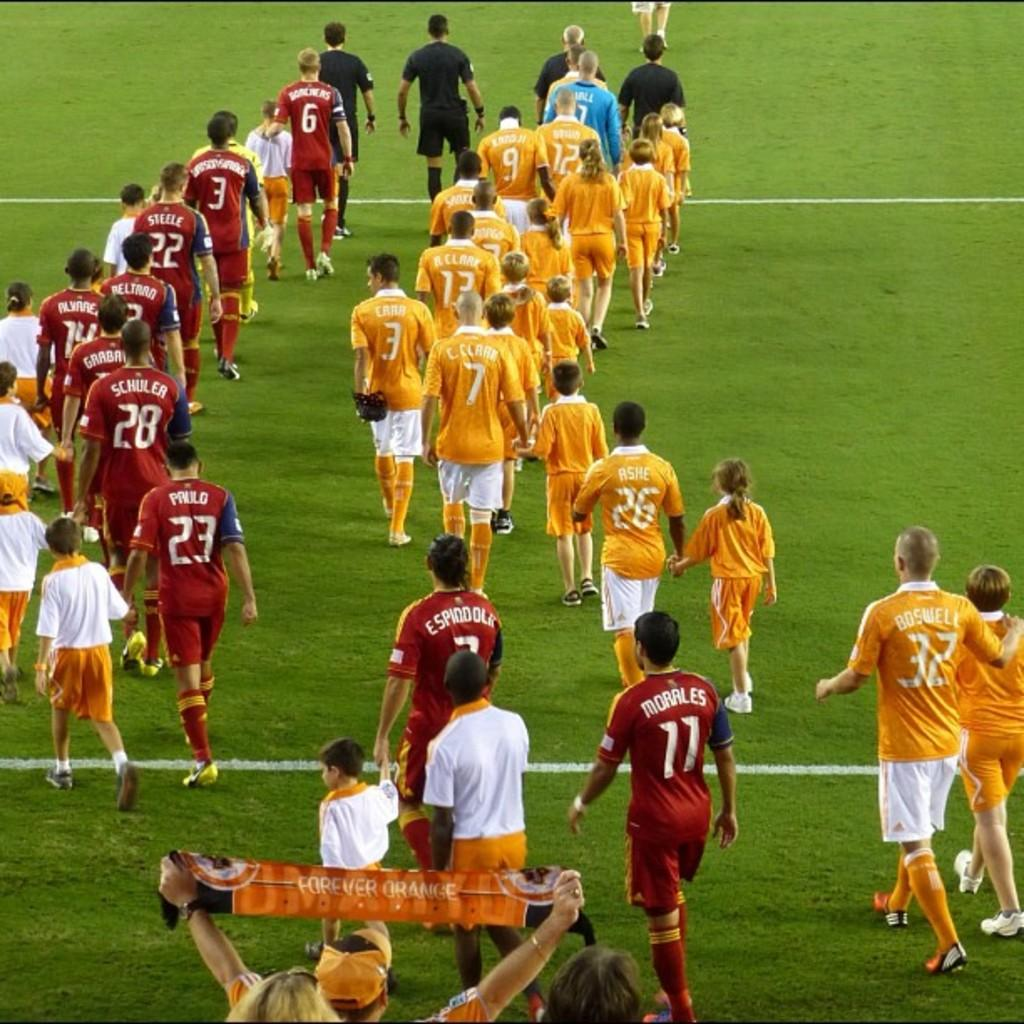How many people are in the image? There is a group of people in the image. What is the setting of the image? The people are standing on a grass field. Is there any text visible in the image? Yes, there is a person holding a banner with text in the image. Where is the banner located in the image? The banner is at the bottom of the image. Can you see the person's father in the image? There is no information about the person's father in the image, so we cannot determine if they are present or not. Is there a lake visible in the image? No, there is no lake present in the image; it features a group of people standing on a grass field. 